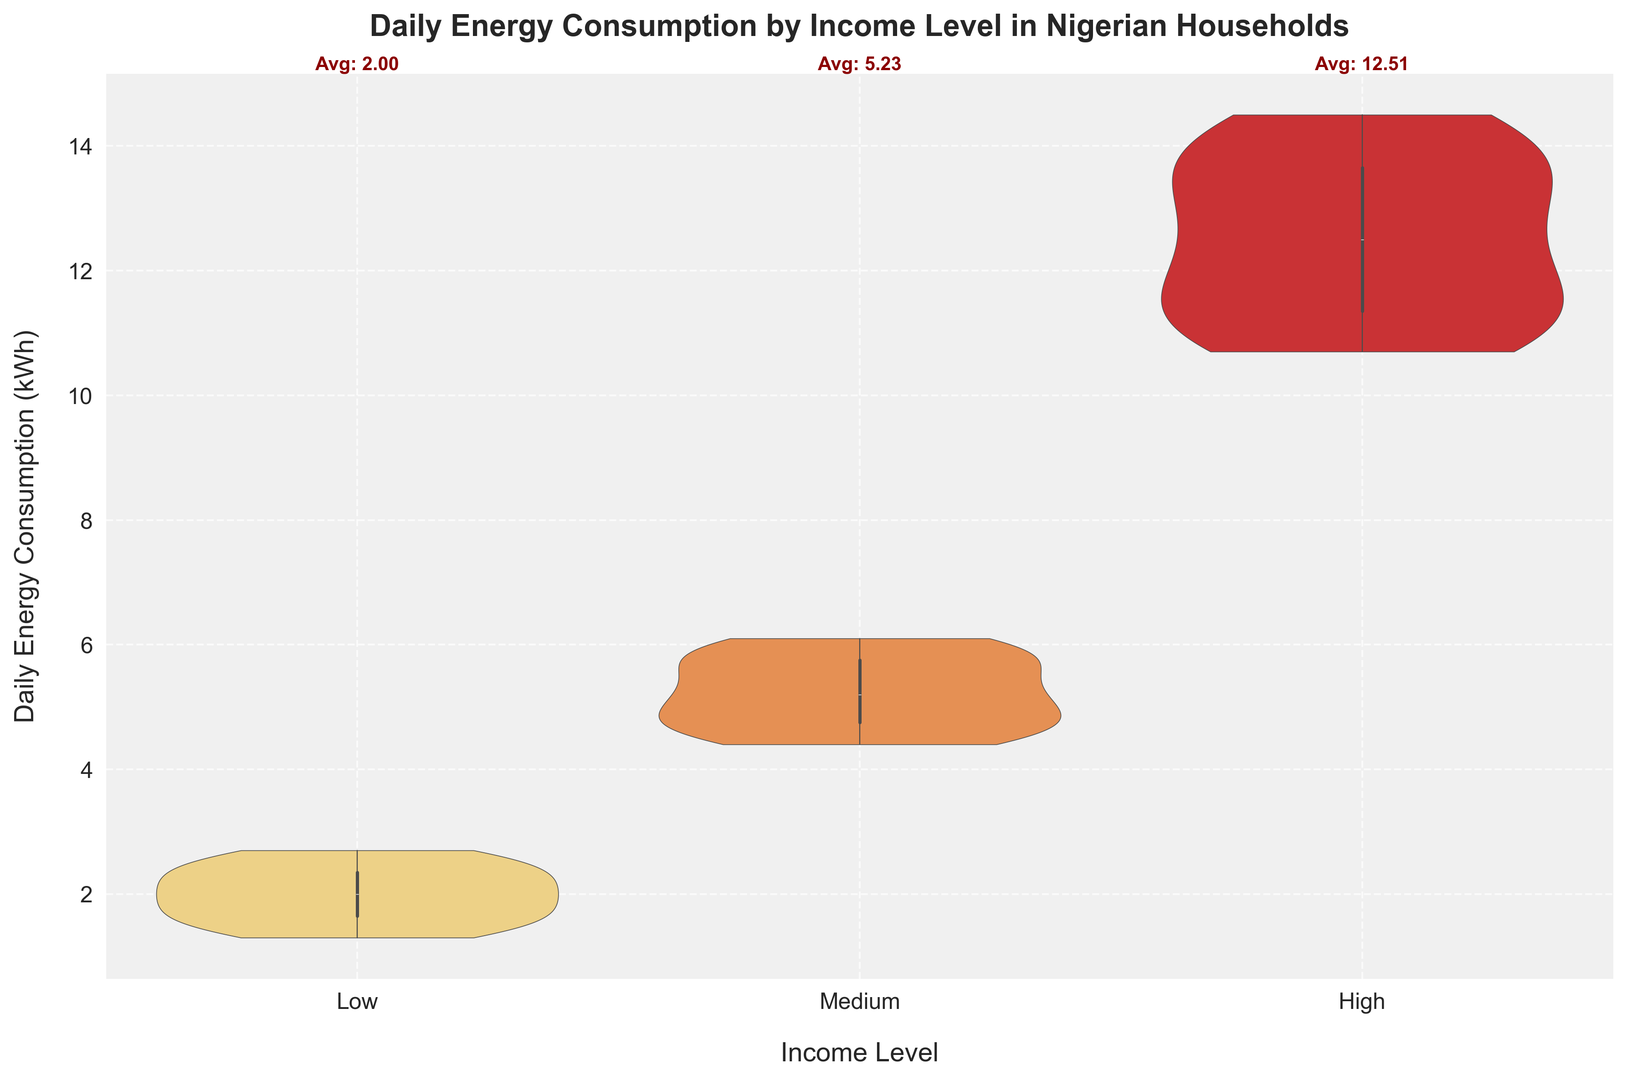What is the average daily energy consumption for low-income households? The plot shows the average daily energy consumption for low-income households annotated above the Low category. By looking at the annotation, we can directly find the value.
Answer: 1.95 kWh Which income level has the highest median daily energy consumption? We can determine the median by observing the central line in the box of each violin plot. The central line for the High-income category appears to be higher compared to the other categories.
Answer: High Which income level has a wider spread of daily energy consumption values? The spread can be determined by looking at the height of the violin plot. The High-income category has the tallest plot, indicating a wider spread of values.
Answer: High How does the average daily energy consumption for medium-income households compare to that of low-income households? The average value for Medium-income households is annotated above the Medium category, and for Low-income, it's above the Low category. Comparing these values shows that the Medium group has a higher average.
Answer: Higher What is the approximate range of daily energy consumption for high-income households? The range is determined by the highest and lowest points in the High-income violin plot. The plot spans from around 10.7 kWh to 14.5 kWh.
Answer: Approximately 10.7 - 14.5 kWh Which income level has the most compact distribution of daily energy consumption? A more compact distribution is represented by a shorter height of the violin plot. The Low-income category has the shortest plot height, indicating a more compact distribution.
Answer: Low What visual feature distinguishes the distribution of high-income household consumption compared to the others? The high-income distribution has a distinctly taller and more spread-out violin plot and extends higher on the y-axis, showing it has greater variability and a higher range of values.
Answer: Tall height and wider spread Between the low and medium-income levels, which has a higher interquartile range (IQR) for daily energy consumption? The interquartile range is represented by the box width inside each violin plot. The box width for Medium-income appears larger compared to the Low-income, indicating a higher IQR.
Answer: Medium How does the lowest point of daily energy consumption for low-income households compare to that of medium-income households? The lowest point of the Low-income distribution is around 1.3 kWh, whereas for Medium-income households it's around 4.4 kWh, as seen by the bottom of the violin plots.
Answer: Lower 